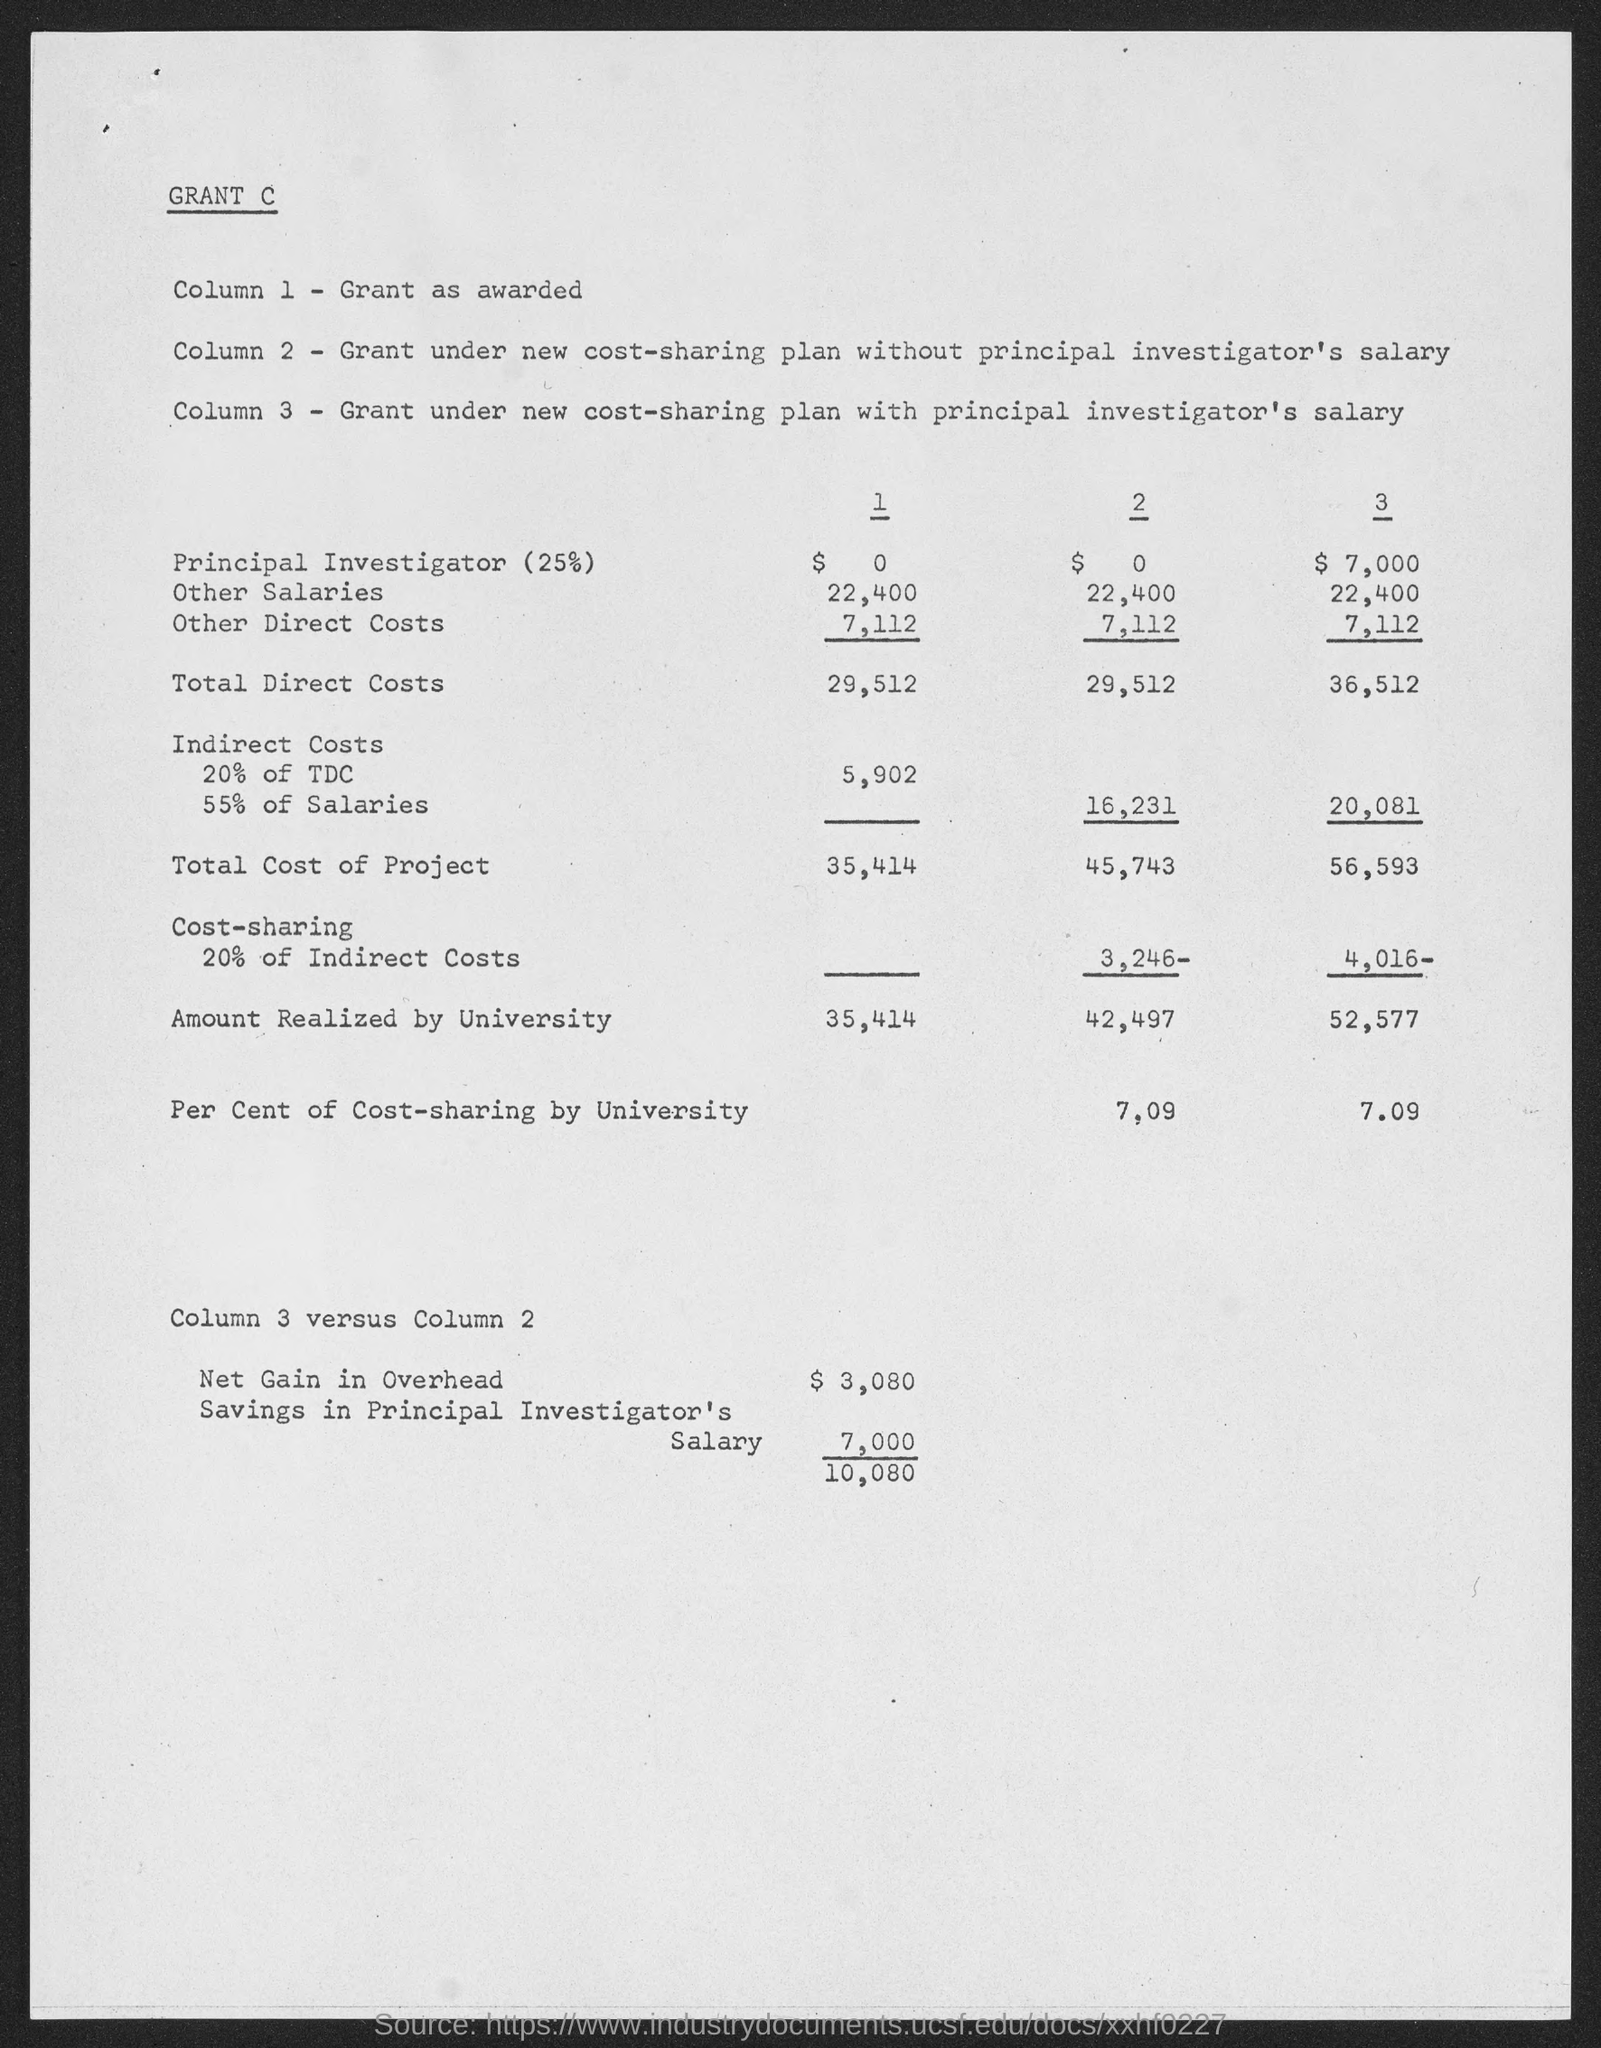Highlight a few significant elements in this photo. Column 1 contains the grant as awarded, starting with 'Grant as awarded.' 